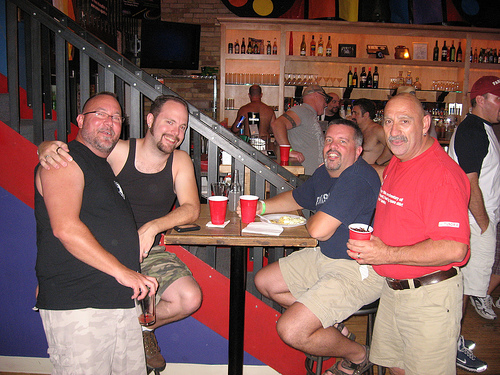<image>
Can you confirm if the cup is on the table? No. The cup is not positioned on the table. They may be near each other, but the cup is not supported by or resting on top of the table. 